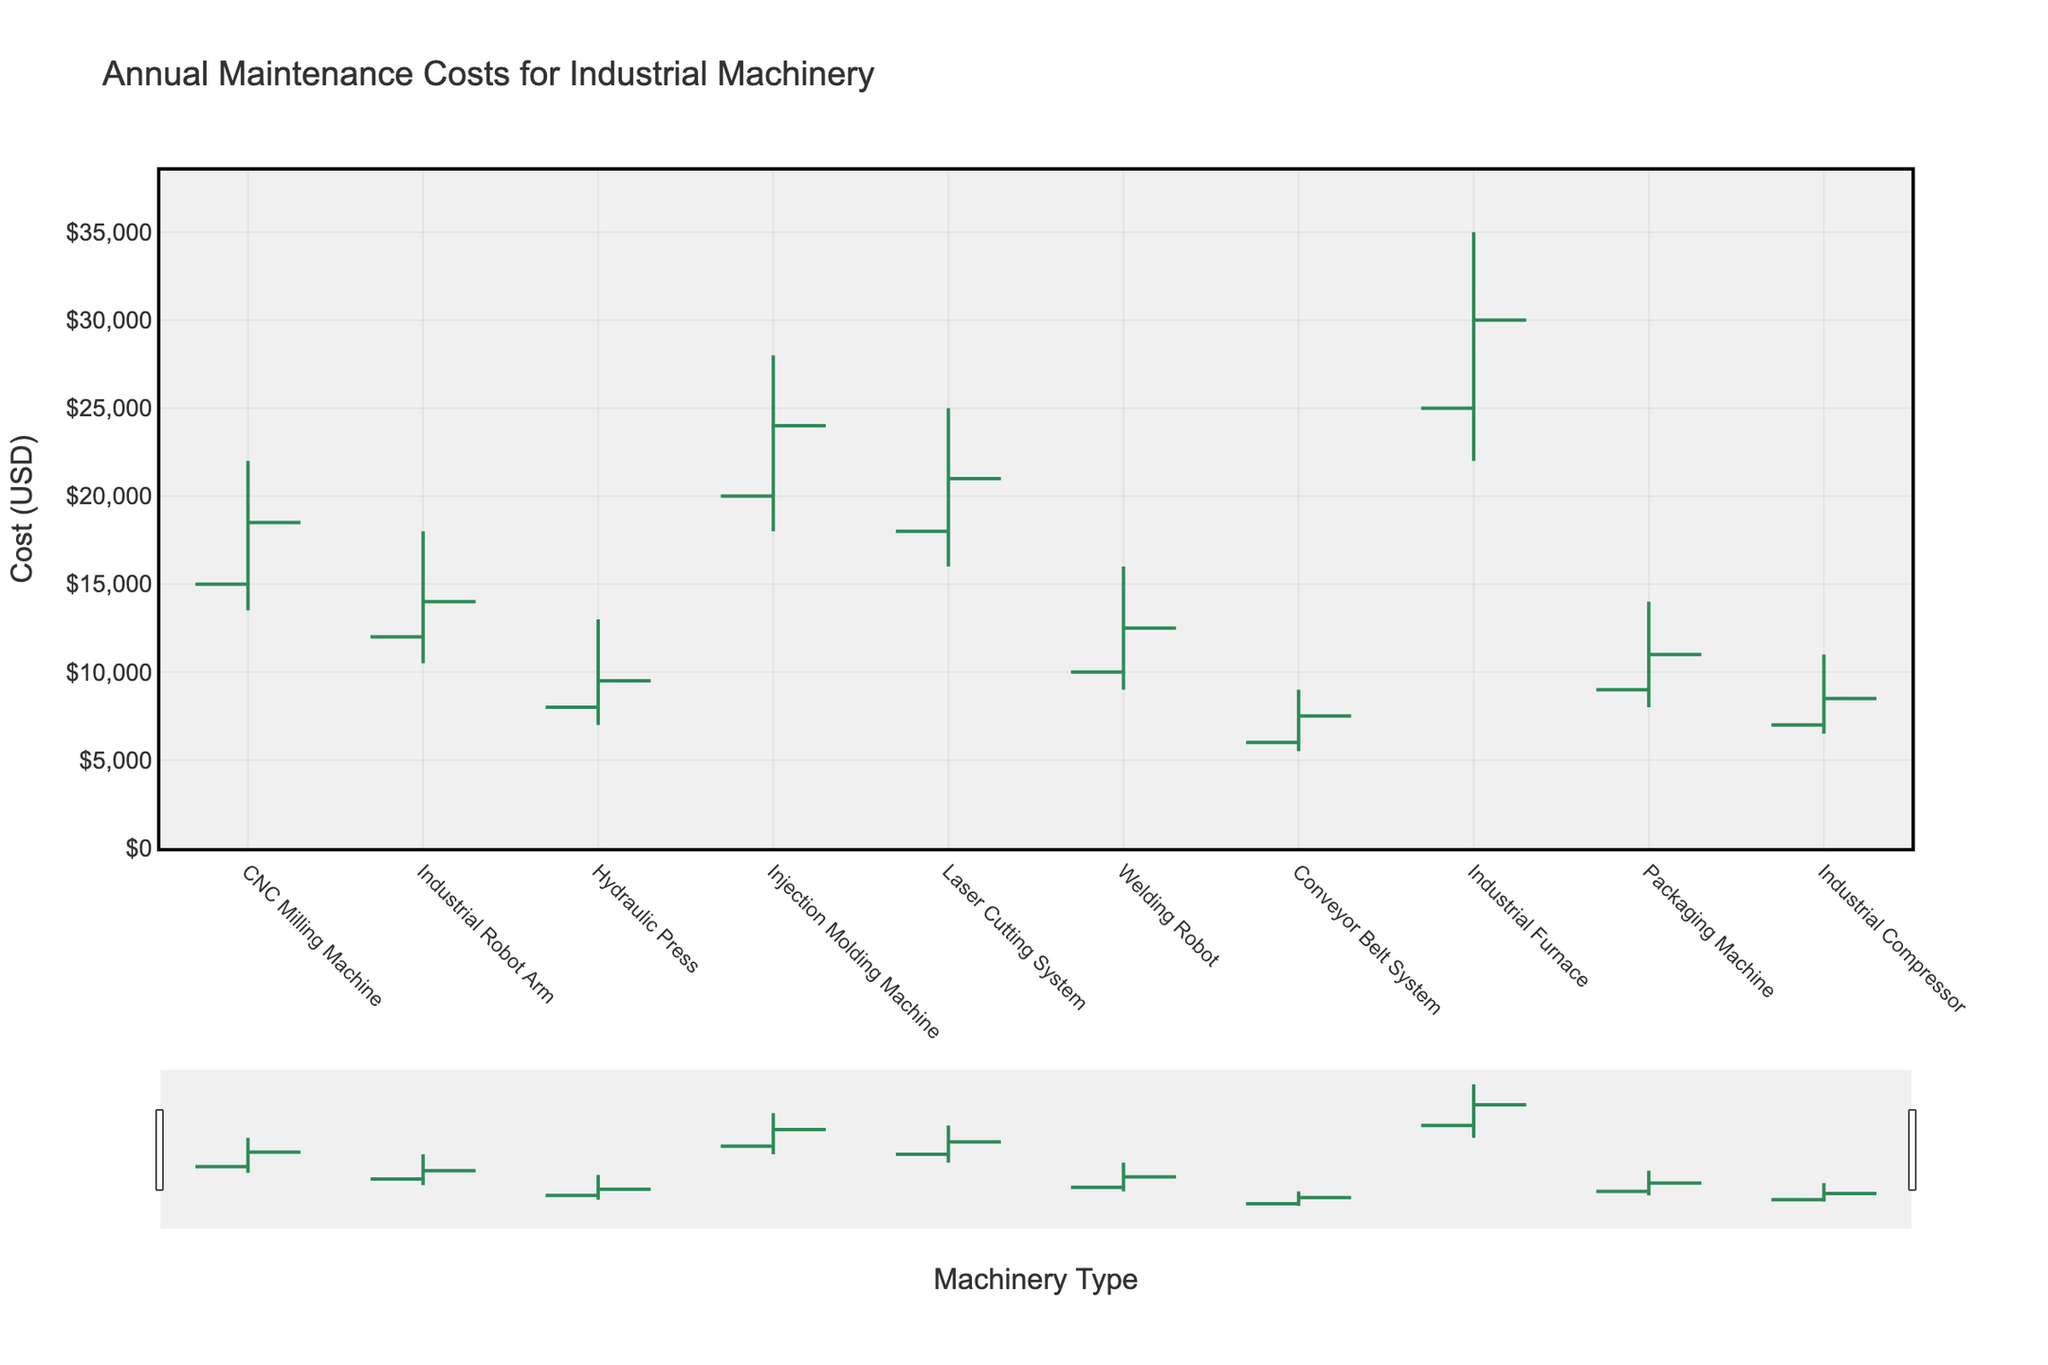How many types of machinery are represented in the plot? There are 10 types of machinery listed in the dataset and each type is represented in the plot.
Answer: 10 Which machinery has the highest initial estimate? The initial estimates for each machinery type are represented by the starting points of the bars. The Industrial Furnace has the highest initial estimate at 25,000 USD.
Answer: Industrial Furnace What is the range of maintenance costs for the Industrial Robot Arm? The range is determined by subtracting the minimum cost from the maximum overrun. For the Industrial Robot Arm, the range is 18,000 - 10,500 = 7,500 USD.
Answer: 7,500 USD How much did the actual costs overrun from the initial estimate for the CNC Milling Machine? The overrun is calculated by subtracting the initial estimate from the final expenditure. For the CNC Milling Machine, it is 18,500 - 15,000 = 3,500 USD.
Answer: 3,500 USD Which machinery type has the smallest difference between its maximum overrun and minimum cost? By comparing the difference between the maximum overrun and minimum cost for each machinery type, the Conveyor Belt System has the smallest difference of 9,000 - 5,500 = 3,500 USD.
Answer: Conveyor Belt System Which machinery had the lowest final expenditure? The final expenditure is represented by the end of the bars. The Conveyor Belt System has the lowest final expenditure at 7,500 USD.
Answer: Conveyor Belt System What is the median final expenditure across all machinery types? To find the median, list all final expenditures in ascending order: 7,500, 8,500, 9,500, 11,000, 12,500, 14,000, 18,500, 21,000, 24,000, 30,000. The median is the average of the 5th and 6th values: (12,500 + 14,000) / 2 = 13,250 USD.
Answer: 13,250 USD Which machinery type has the most significant drop from the initial estimate to the minimum cost? The drop is calculated by subtracting the minimum cost from the initial estimate. The Industrial Furnace has the most significant drop of 25,000 - 22,000 = 3,000 USD.
Answer: Industrial Furnace Is there any type of machinery whose final expenditure is closer to its minimum cost than the initial estimate? Comparing the differences, for the Welding Robot, the final expenditure (12,500) is closer to its minimum cost (9,000) than to its initial estimate (10,000).
Answer: Welding Robot 